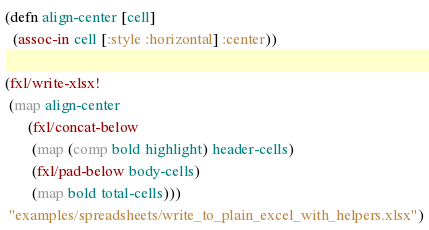<code> <loc_0><loc_0><loc_500><loc_500><_Clojure_>
(defn align-center [cell]
  (assoc-in cell [:style :horizontal] :center))

(fxl/write-xlsx!
 (map align-center
      (fxl/concat-below
       (map (comp bold highlight) header-cells)
       (fxl/pad-below body-cells)
       (map bold total-cells)))
 "examples/spreadsheets/write_to_plain_excel_with_helpers.xlsx")
</code> 